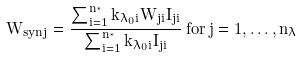Convert formula to latex. <formula><loc_0><loc_0><loc_500><loc_500>W _ { s y n j } = \frac { \sum _ { i = 1 } ^ { n _ { ^ { * } } } k _ { \lambda _ { 0 } i } W _ { j i } I _ { j i } } { \sum _ { i = 1 } ^ { n _ { ^ { * } } } k _ { \lambda _ { 0 } i } I _ { j i } } \, f o r \, j = 1 , \dots , n _ { \lambda }</formula> 